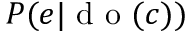Convert formula to latex. <formula><loc_0><loc_0><loc_500><loc_500>P ( e | d o ( c ) )</formula> 